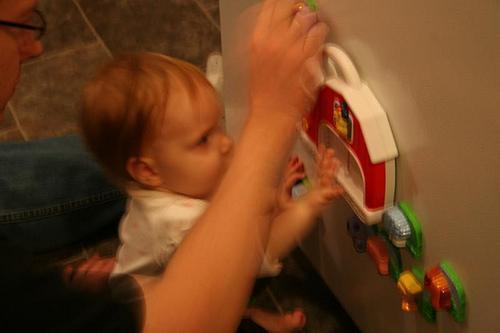How many people are there?
Give a very brief answer. 2. 